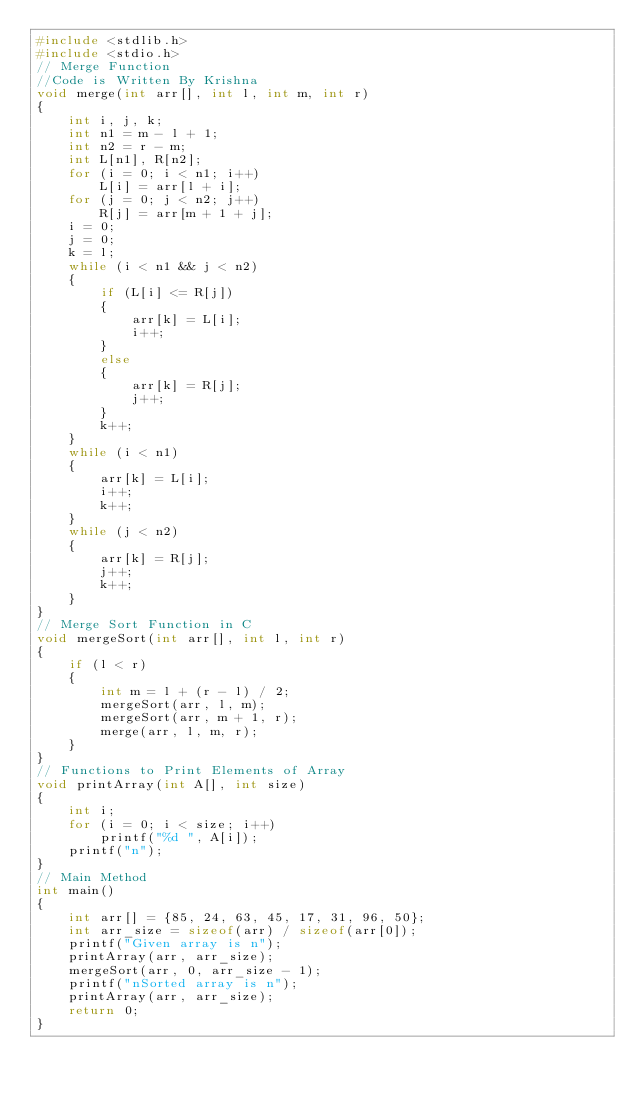Convert code to text. <code><loc_0><loc_0><loc_500><loc_500><_C_>#include <stdlib.h>
#include <stdio.h>
// Merge Function
//Code is Written By Krishna
void merge(int arr[], int l, int m, int r)
{
    int i, j, k;
    int n1 = m - l + 1;
    int n2 = r - m;
    int L[n1], R[n2];
    for (i = 0; i < n1; i++)
        L[i] = arr[l + i];
    for (j = 0; j < n2; j++)
        R[j] = arr[m + 1 + j];
    i = 0;
    j = 0;
    k = l;
    while (i < n1 && j < n2)
    {
        if (L[i] <= R[j])
        {
            arr[k] = L[i];
            i++;
        }
        else
        {
            arr[k] = R[j];
            j++;
        }
        k++;
    }
    while (i < n1)
    {
        arr[k] = L[i];
        i++;
        k++;
    }
    while (j < n2)
    {
        arr[k] = R[j];
        j++;
        k++;
    }
}
// Merge Sort Function in C
void mergeSort(int arr[], int l, int r)
{
    if (l < r)
    {
        int m = l + (r - l) / 2;
        mergeSort(arr, l, m);
        mergeSort(arr, m + 1, r);
        merge(arr, l, m, r);
    }
}
// Functions to Print Elements of Array
void printArray(int A[], int size)
{
    int i;
    for (i = 0; i < size; i++)
        printf("%d ", A[i]);
    printf("n");
}
// Main Method
int main()
{
    int arr[] = {85, 24, 63, 45, 17, 31, 96, 50};
    int arr_size = sizeof(arr) / sizeof(arr[0]);
    printf("Given array is n");
    printArray(arr, arr_size);
    mergeSort(arr, 0, arr_size - 1);
    printf("nSorted array is n");
    printArray(arr, arr_size);
    return 0;
}</code> 